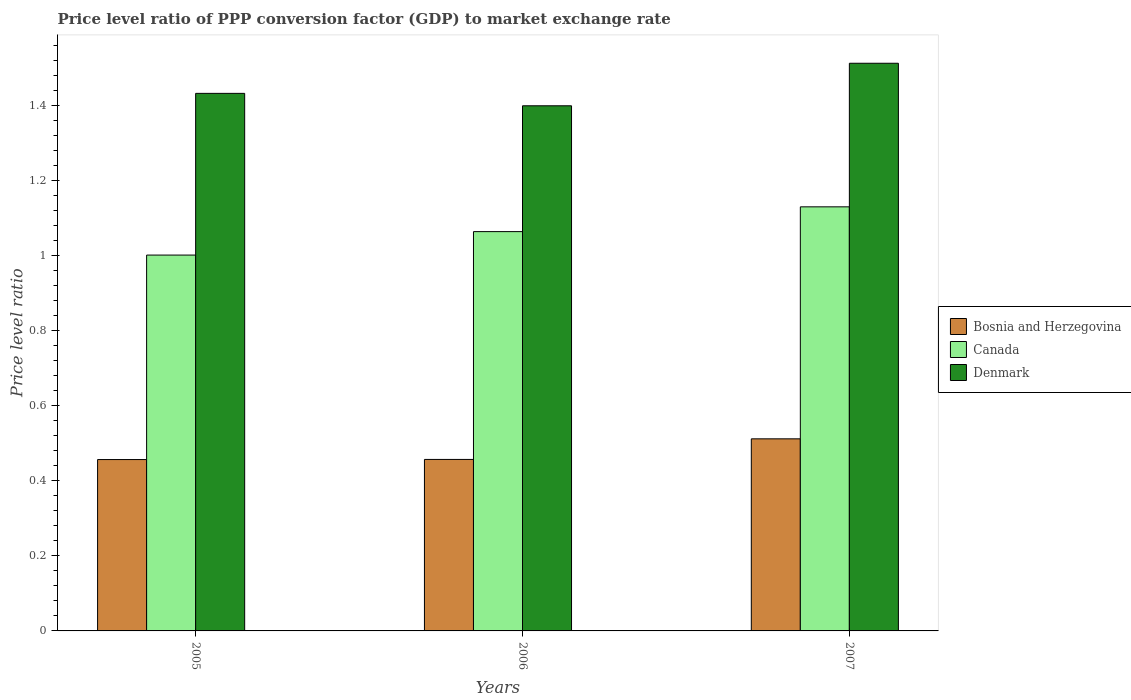How many groups of bars are there?
Offer a terse response. 3. Are the number of bars on each tick of the X-axis equal?
Provide a short and direct response. Yes. What is the price level ratio in Bosnia and Herzegovina in 2007?
Offer a terse response. 0.51. Across all years, what is the maximum price level ratio in Denmark?
Give a very brief answer. 1.51. Across all years, what is the minimum price level ratio in Canada?
Provide a succinct answer. 1. In which year was the price level ratio in Denmark maximum?
Make the answer very short. 2007. In which year was the price level ratio in Denmark minimum?
Provide a succinct answer. 2006. What is the total price level ratio in Bosnia and Herzegovina in the graph?
Ensure brevity in your answer.  1.43. What is the difference between the price level ratio in Bosnia and Herzegovina in 2005 and that in 2007?
Offer a terse response. -0.06. What is the difference between the price level ratio in Canada in 2005 and the price level ratio in Denmark in 2006?
Provide a succinct answer. -0.4. What is the average price level ratio in Denmark per year?
Keep it short and to the point. 1.45. In the year 2006, what is the difference between the price level ratio in Canada and price level ratio in Denmark?
Give a very brief answer. -0.34. What is the ratio of the price level ratio in Denmark in 2005 to that in 2007?
Give a very brief answer. 0.95. Is the price level ratio in Bosnia and Herzegovina in 2005 less than that in 2007?
Provide a short and direct response. Yes. Is the difference between the price level ratio in Canada in 2006 and 2007 greater than the difference between the price level ratio in Denmark in 2006 and 2007?
Give a very brief answer. Yes. What is the difference between the highest and the second highest price level ratio in Bosnia and Herzegovina?
Your answer should be compact. 0.05. What is the difference between the highest and the lowest price level ratio in Bosnia and Herzegovina?
Give a very brief answer. 0.06. In how many years, is the price level ratio in Bosnia and Herzegovina greater than the average price level ratio in Bosnia and Herzegovina taken over all years?
Give a very brief answer. 1. Is the sum of the price level ratio in Bosnia and Herzegovina in 2006 and 2007 greater than the maximum price level ratio in Canada across all years?
Your answer should be compact. No. Is it the case that in every year, the sum of the price level ratio in Denmark and price level ratio in Canada is greater than the price level ratio in Bosnia and Herzegovina?
Give a very brief answer. Yes. Are all the bars in the graph horizontal?
Provide a succinct answer. No. What is the difference between two consecutive major ticks on the Y-axis?
Offer a very short reply. 0.2. Are the values on the major ticks of Y-axis written in scientific E-notation?
Offer a very short reply. No. How many legend labels are there?
Your answer should be very brief. 3. What is the title of the graph?
Ensure brevity in your answer.  Price level ratio of PPP conversion factor (GDP) to market exchange rate. What is the label or title of the X-axis?
Make the answer very short. Years. What is the label or title of the Y-axis?
Provide a succinct answer. Price level ratio. What is the Price level ratio of Bosnia and Herzegovina in 2005?
Keep it short and to the point. 0.46. What is the Price level ratio of Canada in 2005?
Your response must be concise. 1. What is the Price level ratio of Denmark in 2005?
Your answer should be compact. 1.43. What is the Price level ratio in Bosnia and Herzegovina in 2006?
Make the answer very short. 0.46. What is the Price level ratio of Canada in 2006?
Keep it short and to the point. 1.06. What is the Price level ratio of Denmark in 2006?
Provide a short and direct response. 1.4. What is the Price level ratio of Bosnia and Herzegovina in 2007?
Your answer should be very brief. 0.51. What is the Price level ratio of Canada in 2007?
Your answer should be very brief. 1.13. What is the Price level ratio in Denmark in 2007?
Make the answer very short. 1.51. Across all years, what is the maximum Price level ratio in Bosnia and Herzegovina?
Provide a succinct answer. 0.51. Across all years, what is the maximum Price level ratio of Canada?
Give a very brief answer. 1.13. Across all years, what is the maximum Price level ratio in Denmark?
Offer a very short reply. 1.51. Across all years, what is the minimum Price level ratio of Bosnia and Herzegovina?
Make the answer very short. 0.46. Across all years, what is the minimum Price level ratio of Canada?
Make the answer very short. 1. Across all years, what is the minimum Price level ratio of Denmark?
Your response must be concise. 1.4. What is the total Price level ratio in Bosnia and Herzegovina in the graph?
Your answer should be compact. 1.43. What is the total Price level ratio of Canada in the graph?
Make the answer very short. 3.2. What is the total Price level ratio in Denmark in the graph?
Provide a short and direct response. 4.34. What is the difference between the Price level ratio of Bosnia and Herzegovina in 2005 and that in 2006?
Give a very brief answer. -0. What is the difference between the Price level ratio of Canada in 2005 and that in 2006?
Give a very brief answer. -0.06. What is the difference between the Price level ratio in Denmark in 2005 and that in 2006?
Make the answer very short. 0.03. What is the difference between the Price level ratio of Bosnia and Herzegovina in 2005 and that in 2007?
Your response must be concise. -0.06. What is the difference between the Price level ratio in Canada in 2005 and that in 2007?
Keep it short and to the point. -0.13. What is the difference between the Price level ratio of Denmark in 2005 and that in 2007?
Your answer should be very brief. -0.08. What is the difference between the Price level ratio in Bosnia and Herzegovina in 2006 and that in 2007?
Offer a terse response. -0.05. What is the difference between the Price level ratio of Canada in 2006 and that in 2007?
Your answer should be compact. -0.07. What is the difference between the Price level ratio of Denmark in 2006 and that in 2007?
Give a very brief answer. -0.11. What is the difference between the Price level ratio in Bosnia and Herzegovina in 2005 and the Price level ratio in Canada in 2006?
Provide a succinct answer. -0.61. What is the difference between the Price level ratio of Bosnia and Herzegovina in 2005 and the Price level ratio of Denmark in 2006?
Offer a terse response. -0.94. What is the difference between the Price level ratio in Canada in 2005 and the Price level ratio in Denmark in 2006?
Give a very brief answer. -0.4. What is the difference between the Price level ratio in Bosnia and Herzegovina in 2005 and the Price level ratio in Canada in 2007?
Give a very brief answer. -0.67. What is the difference between the Price level ratio in Bosnia and Herzegovina in 2005 and the Price level ratio in Denmark in 2007?
Provide a succinct answer. -1.06. What is the difference between the Price level ratio of Canada in 2005 and the Price level ratio of Denmark in 2007?
Your answer should be very brief. -0.51. What is the difference between the Price level ratio in Bosnia and Herzegovina in 2006 and the Price level ratio in Canada in 2007?
Keep it short and to the point. -0.67. What is the difference between the Price level ratio in Bosnia and Herzegovina in 2006 and the Price level ratio in Denmark in 2007?
Keep it short and to the point. -1.06. What is the difference between the Price level ratio in Canada in 2006 and the Price level ratio in Denmark in 2007?
Your answer should be very brief. -0.45. What is the average Price level ratio of Bosnia and Herzegovina per year?
Provide a succinct answer. 0.48. What is the average Price level ratio of Canada per year?
Your answer should be compact. 1.07. What is the average Price level ratio of Denmark per year?
Provide a succinct answer. 1.45. In the year 2005, what is the difference between the Price level ratio of Bosnia and Herzegovina and Price level ratio of Canada?
Give a very brief answer. -0.54. In the year 2005, what is the difference between the Price level ratio in Bosnia and Herzegovina and Price level ratio in Denmark?
Offer a terse response. -0.98. In the year 2005, what is the difference between the Price level ratio of Canada and Price level ratio of Denmark?
Offer a very short reply. -0.43. In the year 2006, what is the difference between the Price level ratio in Bosnia and Herzegovina and Price level ratio in Canada?
Your response must be concise. -0.61. In the year 2006, what is the difference between the Price level ratio in Bosnia and Herzegovina and Price level ratio in Denmark?
Your answer should be compact. -0.94. In the year 2006, what is the difference between the Price level ratio of Canada and Price level ratio of Denmark?
Keep it short and to the point. -0.34. In the year 2007, what is the difference between the Price level ratio in Bosnia and Herzegovina and Price level ratio in Canada?
Provide a short and direct response. -0.62. In the year 2007, what is the difference between the Price level ratio in Bosnia and Herzegovina and Price level ratio in Denmark?
Keep it short and to the point. -1. In the year 2007, what is the difference between the Price level ratio in Canada and Price level ratio in Denmark?
Your answer should be compact. -0.38. What is the ratio of the Price level ratio of Bosnia and Herzegovina in 2005 to that in 2006?
Ensure brevity in your answer.  1. What is the ratio of the Price level ratio in Canada in 2005 to that in 2006?
Give a very brief answer. 0.94. What is the ratio of the Price level ratio of Denmark in 2005 to that in 2006?
Your response must be concise. 1.02. What is the ratio of the Price level ratio of Bosnia and Herzegovina in 2005 to that in 2007?
Keep it short and to the point. 0.89. What is the ratio of the Price level ratio of Canada in 2005 to that in 2007?
Offer a very short reply. 0.89. What is the ratio of the Price level ratio in Denmark in 2005 to that in 2007?
Your answer should be compact. 0.95. What is the ratio of the Price level ratio in Bosnia and Herzegovina in 2006 to that in 2007?
Give a very brief answer. 0.89. What is the ratio of the Price level ratio in Canada in 2006 to that in 2007?
Your response must be concise. 0.94. What is the ratio of the Price level ratio in Denmark in 2006 to that in 2007?
Offer a very short reply. 0.93. What is the difference between the highest and the second highest Price level ratio in Bosnia and Herzegovina?
Offer a terse response. 0.05. What is the difference between the highest and the second highest Price level ratio in Canada?
Your answer should be very brief. 0.07. What is the difference between the highest and the second highest Price level ratio in Denmark?
Offer a very short reply. 0.08. What is the difference between the highest and the lowest Price level ratio in Bosnia and Herzegovina?
Provide a succinct answer. 0.06. What is the difference between the highest and the lowest Price level ratio in Canada?
Provide a succinct answer. 0.13. What is the difference between the highest and the lowest Price level ratio of Denmark?
Give a very brief answer. 0.11. 